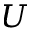Convert formula to latex. <formula><loc_0><loc_0><loc_500><loc_500>U</formula> 